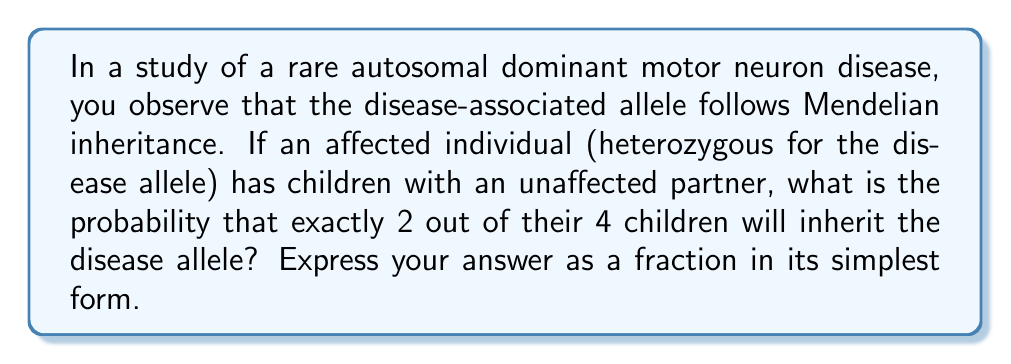Help me with this question. Let's approach this step-by-step:

1) First, we need to understand the inheritance pattern:
   - The disease is autosomal dominant
   - The affected parent is heterozygous (let's say Dd, where D is the disease allele)
   - The unaffected partner is homozygous recessive (dd)

2) For each child, the probability of inheriting the disease allele is 1/2:
   $P(\text{inheriting D}) = \frac{1}{2}$
   $P(\text{not inheriting D}) = \frac{1}{2}$

3) We want exactly 2 out of 4 children to inherit the disease allele. This follows a binomial distribution.

4) The probability of this specific outcome can be calculated using the binomial probability formula:

   $P(X=k) = \binom{n}{k} p^k (1-p)^{n-k}$

   Where:
   $n$ = total number of children = 4
   $k$ = number of children with the disease allele = 2
   $p$ = probability of inheriting the disease allele = 1/2

5) Let's substitute these values:

   $P(X=2) = \binom{4}{2} (\frac{1}{2})^2 (1-\frac{1}{2})^{4-2}$

6) Simplify:
   $P(X=2) = 6 \cdot (\frac{1}{4}) \cdot (\frac{1}{4})$
   $P(X=2) = 6 \cdot \frac{1}{16} = \frac{6}{16} = \frac{3}{8}$

Therefore, the probability of exactly 2 out of 4 children inheriting the disease allele is 3/8.
Answer: $\frac{3}{8}$ 